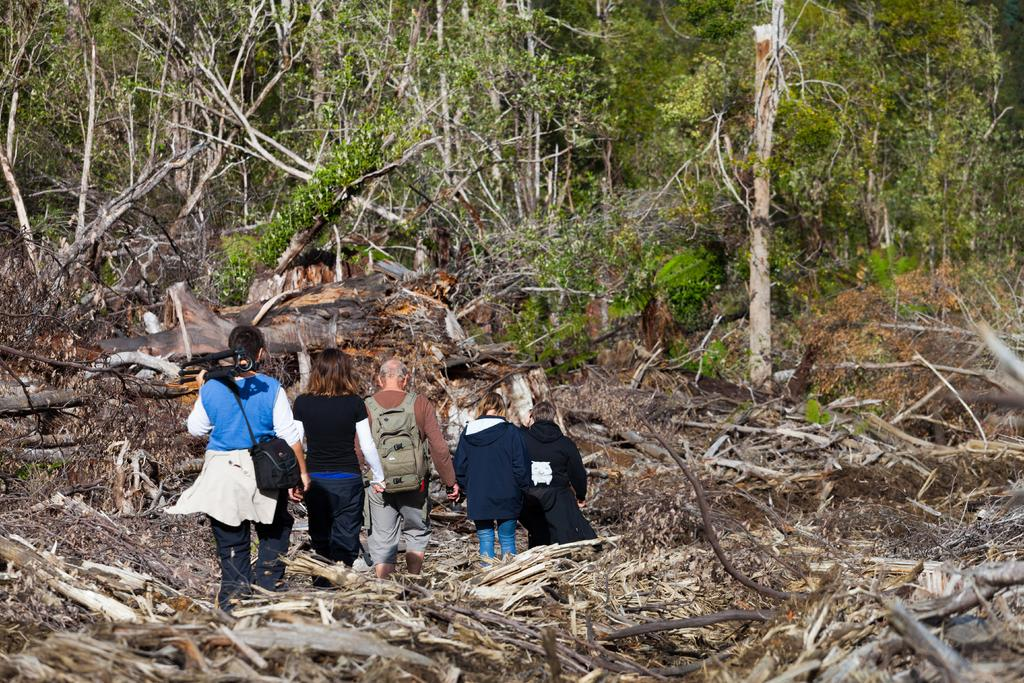What are the people in the image doing? The people in the image are walking. What is the ground made of in the image? The people are walking on dried leaves and branches. What can be seen in the background of the image? There are trees in the background of the image, and the bark of the trees is visible. What type of tank can be seen in the image? There is no tank present in the image. How fast are the people running in the image? The people in the image are walking, not running. 